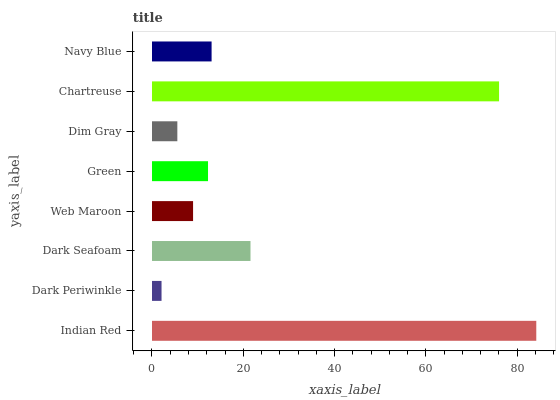Is Dark Periwinkle the minimum?
Answer yes or no. Yes. Is Indian Red the maximum?
Answer yes or no. Yes. Is Dark Seafoam the minimum?
Answer yes or no. No. Is Dark Seafoam the maximum?
Answer yes or no. No. Is Dark Seafoam greater than Dark Periwinkle?
Answer yes or no. Yes. Is Dark Periwinkle less than Dark Seafoam?
Answer yes or no. Yes. Is Dark Periwinkle greater than Dark Seafoam?
Answer yes or no. No. Is Dark Seafoam less than Dark Periwinkle?
Answer yes or no. No. Is Navy Blue the high median?
Answer yes or no. Yes. Is Green the low median?
Answer yes or no. Yes. Is Indian Red the high median?
Answer yes or no. No. Is Dim Gray the low median?
Answer yes or no. No. 